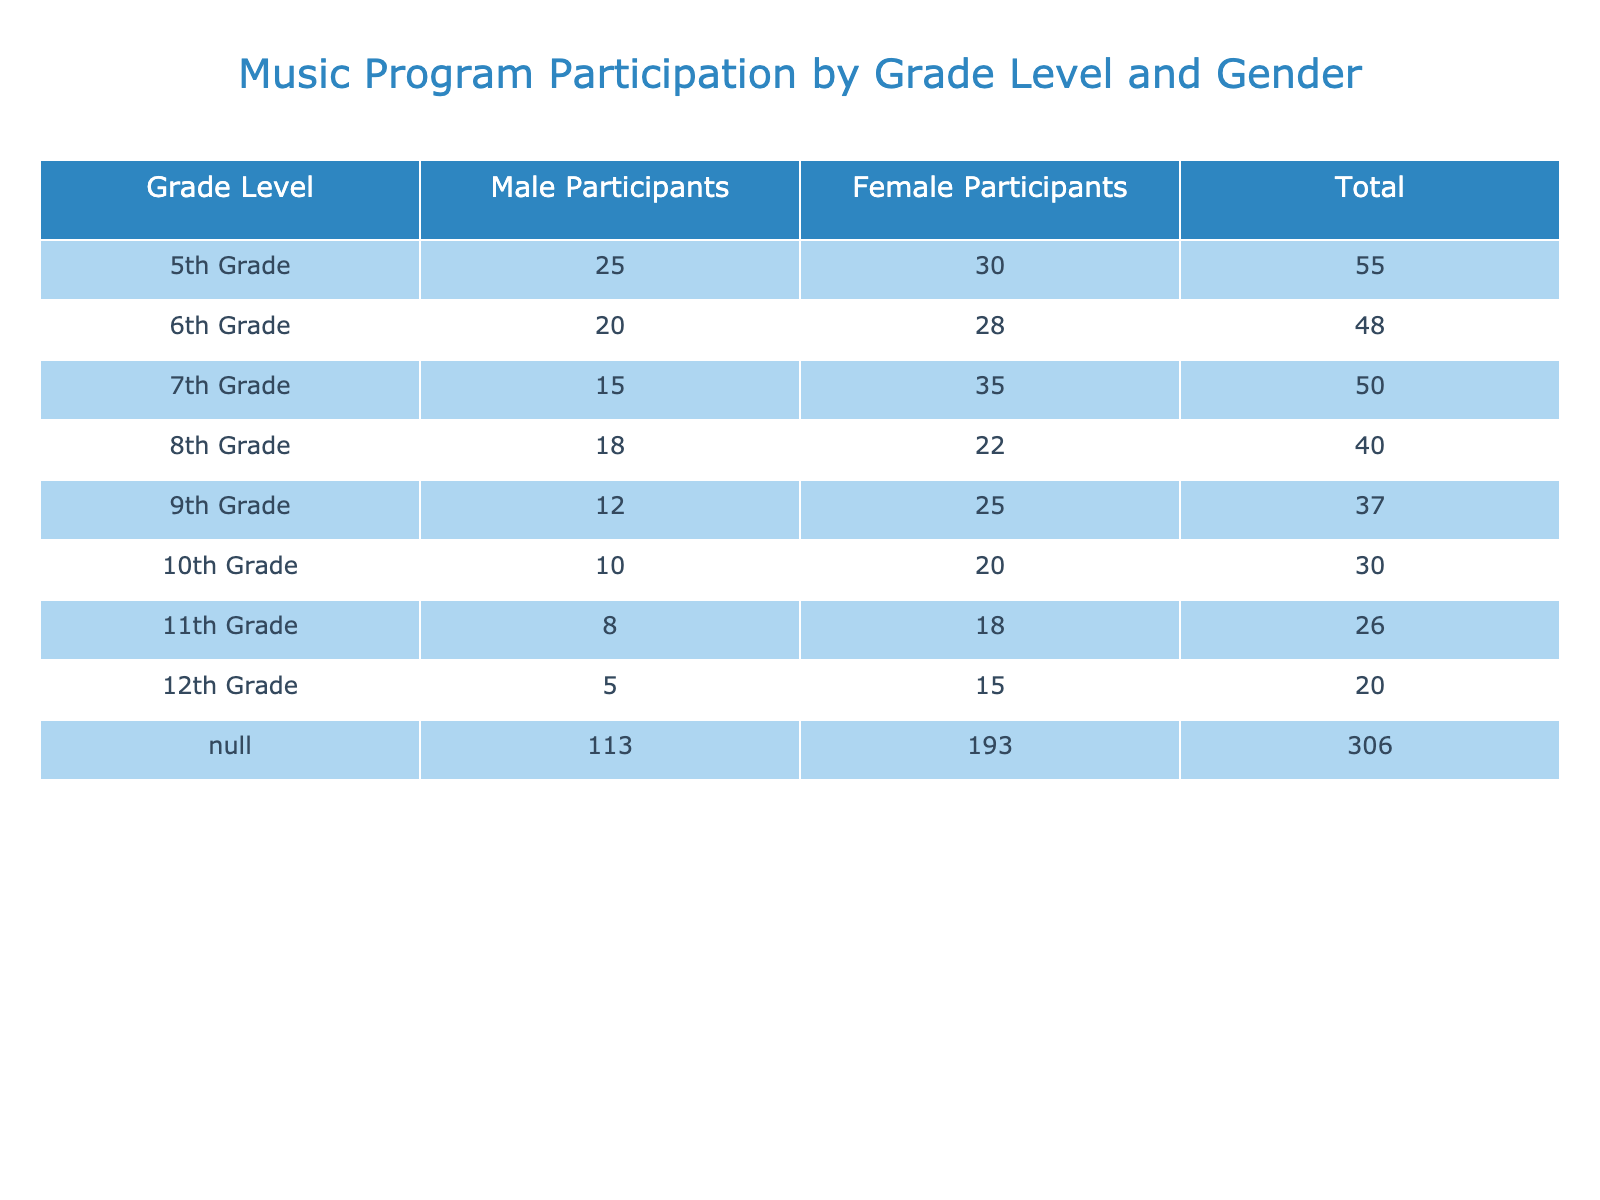What is the total number of male participants in all grades? To find the total number of male participants, we add the number of male participants for each grade level: 25 (5th) + 20 (6th) + 15 (7th) + 18 (8th) + 12 (9th) + 10 (10th) + 8 (11th) + 5 (12th) = 123.
Answer: 123 How many female participants are there in 7th grade? By referring to the table, the number of female participants in 7th grade is clearly stated as 35.
Answer: 35 Which grade has the highest total participation? To find the grade with the highest total participation, we calculate the total number for each grade and compare them: 55 (5th), 48 (6th), 50 (7th), 40 (8th), 37 (9th), 30 (10th), 26 (11th), 20 (12th). The highest is 55 in 5th grade.
Answer: 5th Grade Is the number of female participants in 10th grade greater than the number of male participants in the same grade? In 10th grade, there are 20 female participants and 10 male participants. Since 20 > 10, the statement is true.
Answer: Yes What is the difference in the number of female participants between 6th and 8th grades? The number of female participants in 6th grade is 28 and in 8th grade is 22. We calculate the difference as 28 - 22 = 6.
Answer: 6 What is the average number of participants (male and female) in 11th and 12th grades combined? First, we find the total participants in both grades: 11th grade has 8 males + 18 females = 26, and 12th grade has 5 males + 15 females = 20. The combined total is 26 + 20 = 46. There are 2 grades, so the average is 46 / 2 = 23.
Answer: 23 Which gender has a higher total participation across all grades? Total male participants are 123, and total female participants are 168. Since 168 > 123, females have higher total participation.
Answer: Females In which grade is the difference between male and female participants the smallest? We need to compare the differences for each grade: 5th (5), 6th (8), 7th (20), 8th (4), 9th (13), 10th (10), 11th (10), 12th (10). The smallest difference is 4 in 8th grade.
Answer: 8th Grade 